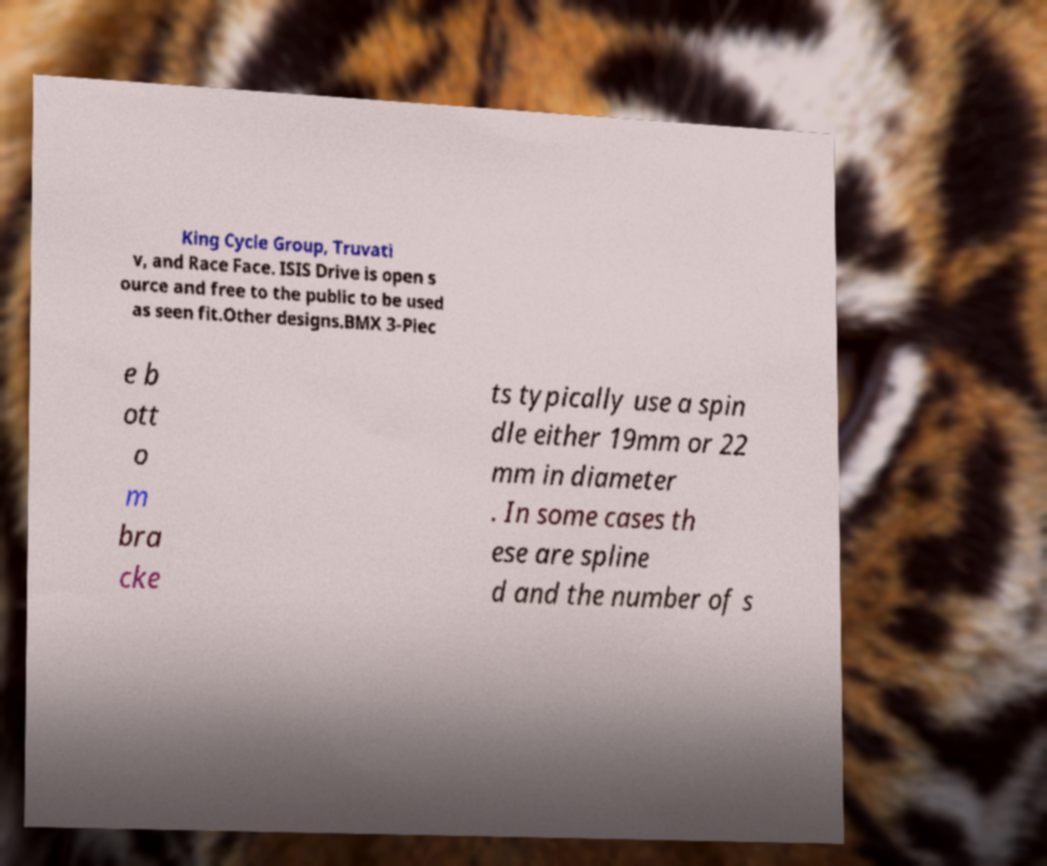Please identify and transcribe the text found in this image. King Cycle Group, Truvati v, and Race Face. ISIS Drive is open s ource and free to the public to be used as seen fit.Other designs.BMX 3-Piec e b ott o m bra cke ts typically use a spin dle either 19mm or 22 mm in diameter . In some cases th ese are spline d and the number of s 